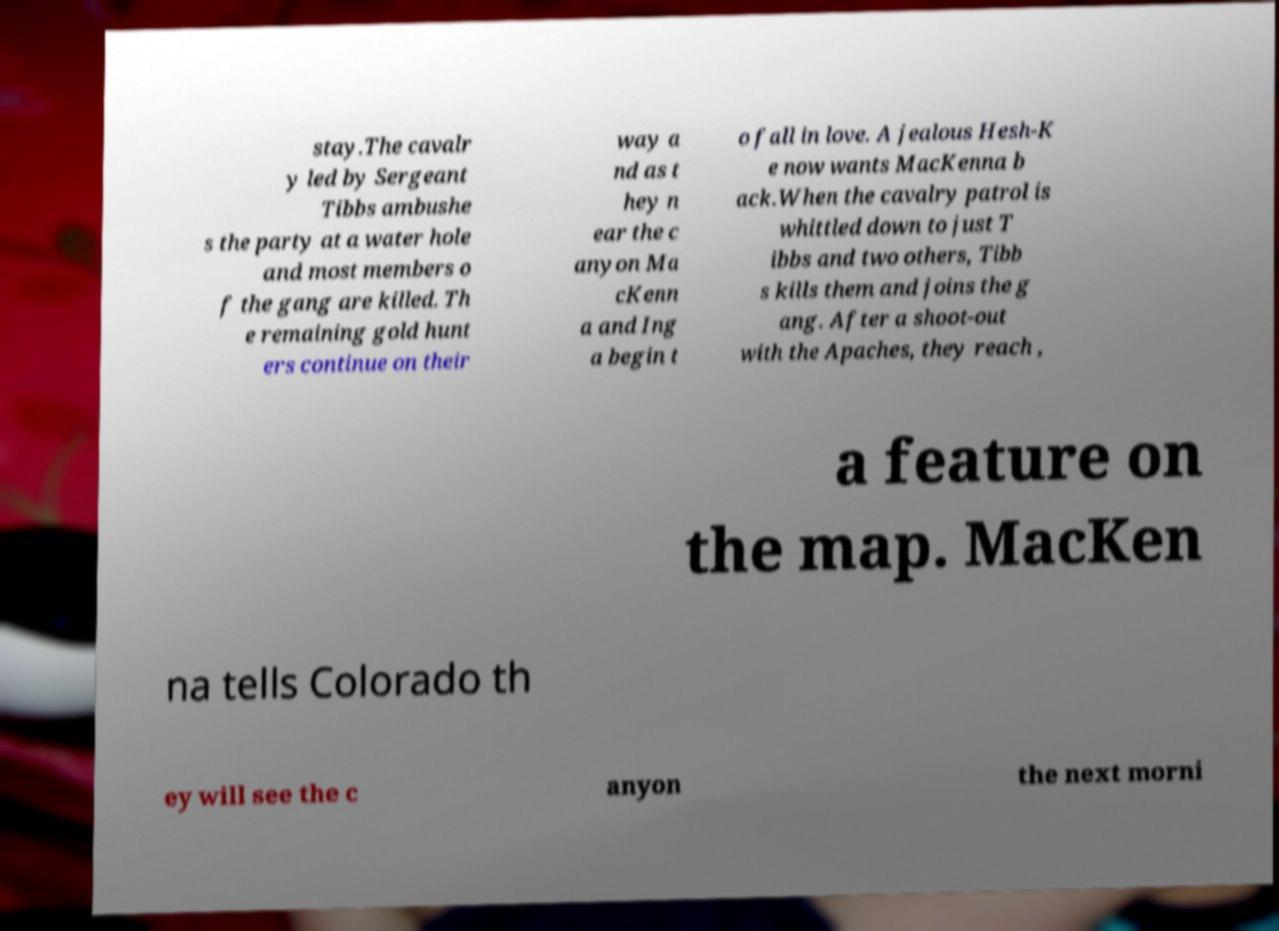Could you extract and type out the text from this image? stay.The cavalr y led by Sergeant Tibbs ambushe s the party at a water hole and most members o f the gang are killed. Th e remaining gold hunt ers continue on their way a nd as t hey n ear the c anyon Ma cKenn a and Ing a begin t o fall in love. A jealous Hesh-K e now wants MacKenna b ack.When the cavalry patrol is whittled down to just T ibbs and two others, Tibb s kills them and joins the g ang. After a shoot-out with the Apaches, they reach , a feature on the map. MacKen na tells Colorado th ey will see the c anyon the next morni 